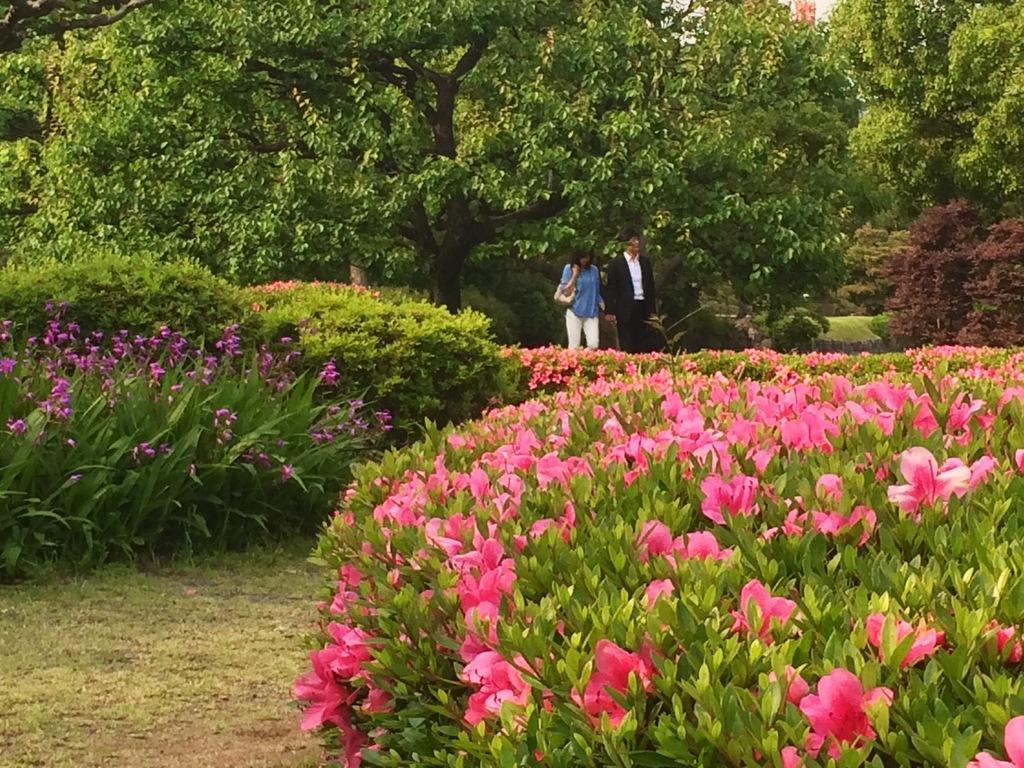How would you summarize this image in a sentence or two? In this picture, we can see a few people, and among them a person is carrying a bag, we can see the ground with grass, plants, flowers, and trees. 